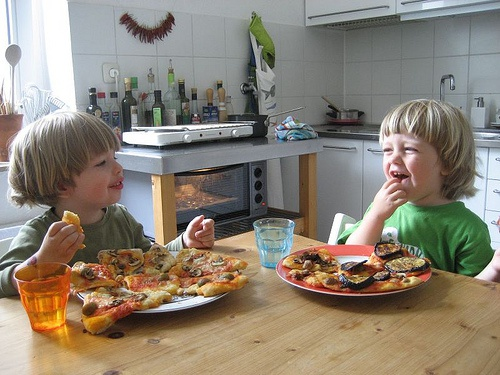Describe the objects in this image and their specific colors. I can see dining table in ivory, tan, gray, brown, and maroon tones, people in ivory, gray, maroon, and black tones, people in ivory, gray, darkgreen, lightgray, and brown tones, pizza in ivory, brown, maroon, and gray tones, and microwave in ivory, gray, black, and darkblue tones in this image. 